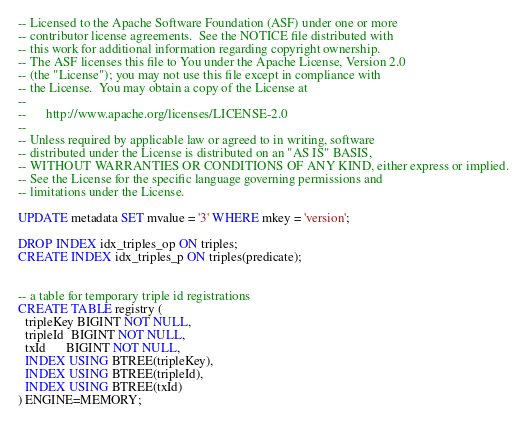<code> <loc_0><loc_0><loc_500><loc_500><_SQL_>-- Licensed to the Apache Software Foundation (ASF) under one or more
-- contributor license agreements.  See the NOTICE file distributed with
-- this work for additional information regarding copyright ownership.
-- The ASF licenses this file to You under the Apache License, Version 2.0
-- (the "License"); you may not use this file except in compliance with
-- the License.  You may obtain a copy of the License at
--
--      http://www.apache.org/licenses/LICENSE-2.0
--
-- Unless required by applicable law or agreed to in writing, software
-- distributed under the License is distributed on an "AS IS" BASIS,
-- WITHOUT WARRANTIES OR CONDITIONS OF ANY KIND, either express or implied.
-- See the License for the specific language governing permissions and
-- limitations under the License.

UPDATE metadata SET mvalue = '3' WHERE mkey = 'version';

DROP INDEX idx_triples_op ON triples;
CREATE INDEX idx_triples_p ON triples(predicate);


-- a table for temporary triple id registrations
CREATE TABLE registry (
  tripleKey BIGINT NOT NULL,
  tripleId  BIGINT NOT NULL,
  txId      BIGINT NOT NULL,
  INDEX USING BTREE(tripleKey),
  INDEX USING BTREE(tripleId),
  INDEX USING BTREE(txId)
) ENGINE=MEMORY;
</code> 